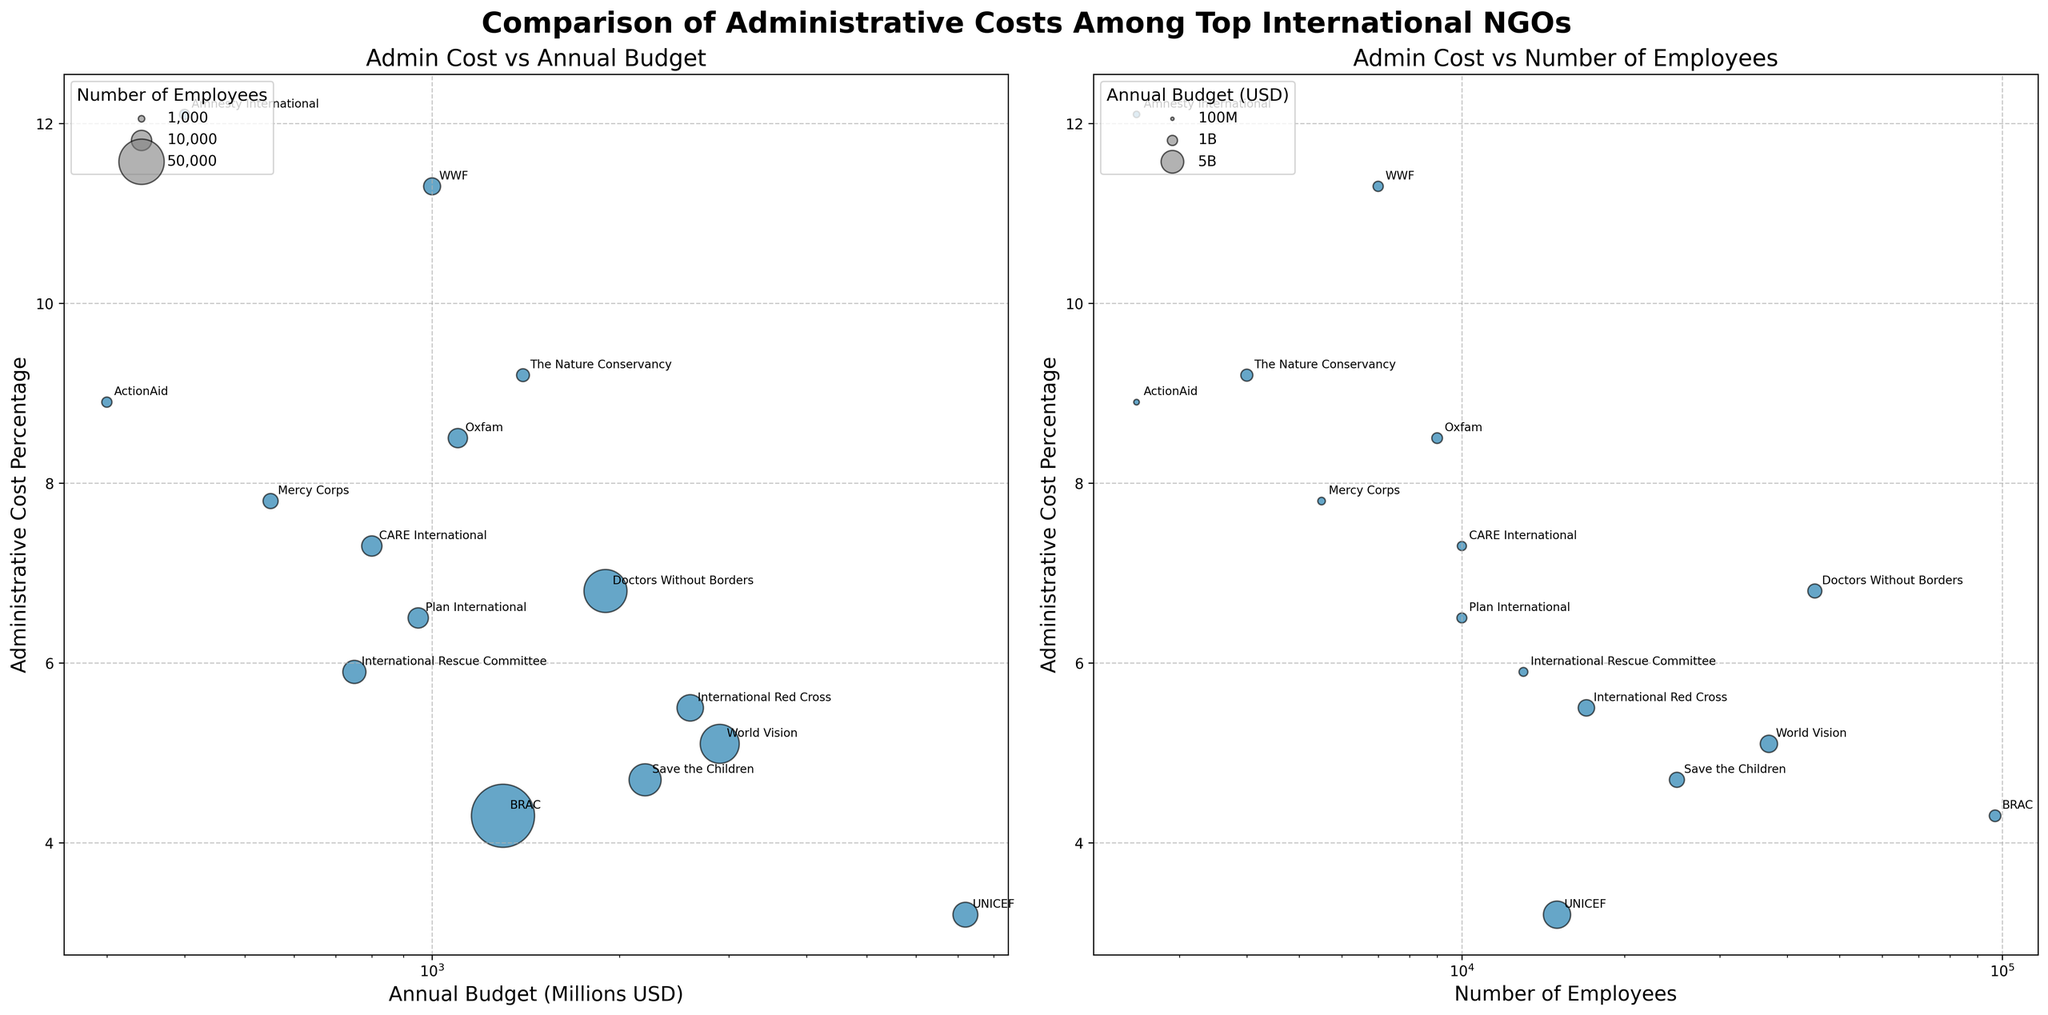What is the title of the figure? The title is at the top center of the figure, written in bold and large font. It states "Comparison of Administrative Costs Among Top International NGOs."
Answer: Comparison of Administrative Costs Among Top International NGOs Which NGO has the highest administrative cost percentage? Locate the y-axis labeled "Administrative Cost Percentage" and identify the bubble that is the highest on that axis. This bubble represents Amnesty International with a percentage of 12.1.
Answer: Amnesty International What is the relationship between the annual budget and administrative cost percentage for UNICEF? In the left subplot, find the bubble for UNICEF and note its position on the x-axis (Annual Budget) and y-axis (Administrative Cost Percentage). UNICEF has a large annual budget (~7200 million USD) and a low administrative cost percentage (3.2%).
Answer: Large budget, low admin cost Which NGO has the largest number of employees but doesn’t have the highest administrative cost percentage? In the right subplot, find the bubble furthest to the right on the x-axis (Number of Employees). This bubble represents BRAC with 97,000 employees and an admin cost of 4.3%, which is not the highest.
Answer: BRAC Among the NGOs focused on Environmental Conservation, which one has the lower administrative cost percentage? Identify the bubbles representing WWF and The Nature Conservancy by their labels. Compare their y-axis positions. WWF has an admin cost of 11.3%, while The Nature Conservancy has 9.2%.
Answer: The Nature Conservancy What is the focus area of the NGO with the smallest bubble in the left subplot? In the left subplot, locate the smallest bubble which represents the size of the annual budget. Identify the label next to this small bubble, which is ActionAid. Confirm its focus area, which is Poverty Alleviation.
Answer: Poverty Alleviation How does the administrative cost percentage of Save the Children compare to CARE International? In both subplots, locate the bubbles for Save the Children and CARE International, then compare their y-axis positions. Save the Children has an admin cost of 4.7%, while CARE International has 7.3%. Save the Children's percentage is lower.
Answer: Save the Children has a lower percentage What is the average annual budget for NGOs focusing on Children's Rights based on the figure? Identify the bubbles for UNICEF, Save the Children, and Plan International, the NGOs focusing on Children's Rights. Sum their annual budgets (7200+2200+950) and divide by 3. Average budget = (7200 + 2200 + 950) / 3 = 3,450 million USD.
Answer: 3,450 million USD What can be inferred about the relationship between the number of employees and the administrative cost percentage from the right subplot? Observe the distribution of bubbles on the right subplot. Generally, there is no clear trend indicating that more employees significantly increase or decrease the administrative cost percentage. Examples include BRAC with many employees but a reasonable admin cost, and Amnesty International with few employees but a high cost.
Answer: No clear trend Which NGO has the lowest administrative cost percentage, and what is its annual budget? Identify the bubble closest to the bottom of the y-axis labeled "Administrative Cost Percentage." This bubble is for UNICEF with an admin cost percentage of 3.2%. Its annual budget is around 7200 million USD.
Answer: UNICEF, 7200 million USD 